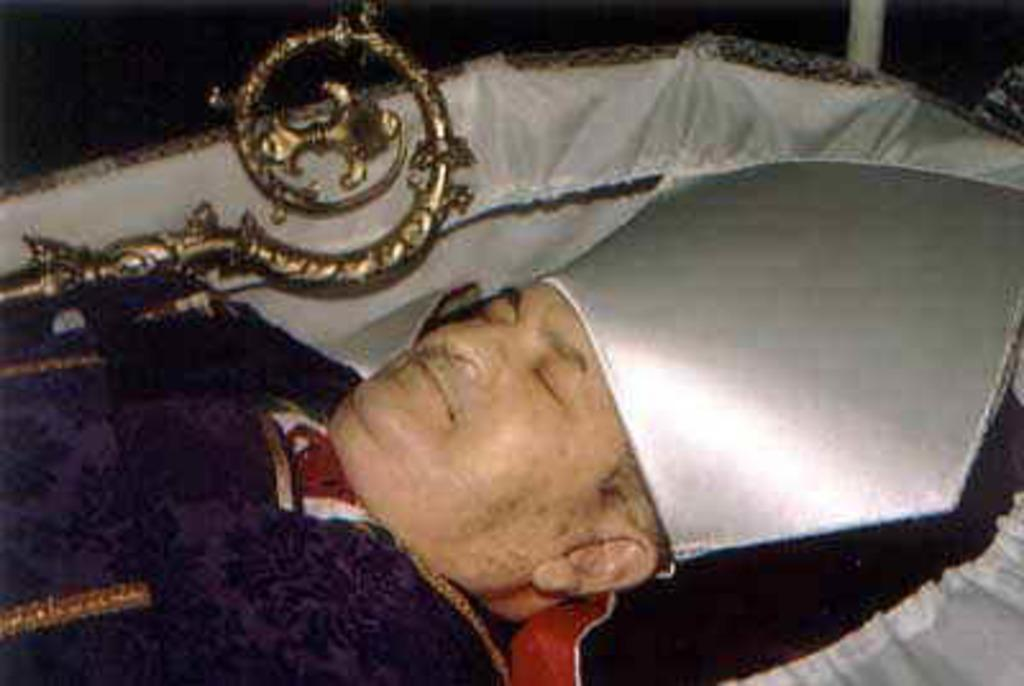What is the main subject of the image? The main subject of the image is a person's dead body in a coffin. Can you describe the object beside the coffin? Unfortunately, the provided facts do not give any information about the object beside the coffin. What type of trousers is the person wearing in the image? The provided facts do not mention any clothing on the person's dead body, so we cannot determine the type of trousers they might be wearing. Where is the library located in the image? There is no mention of a library in the provided facts, so we cannot determine its location in the image. 